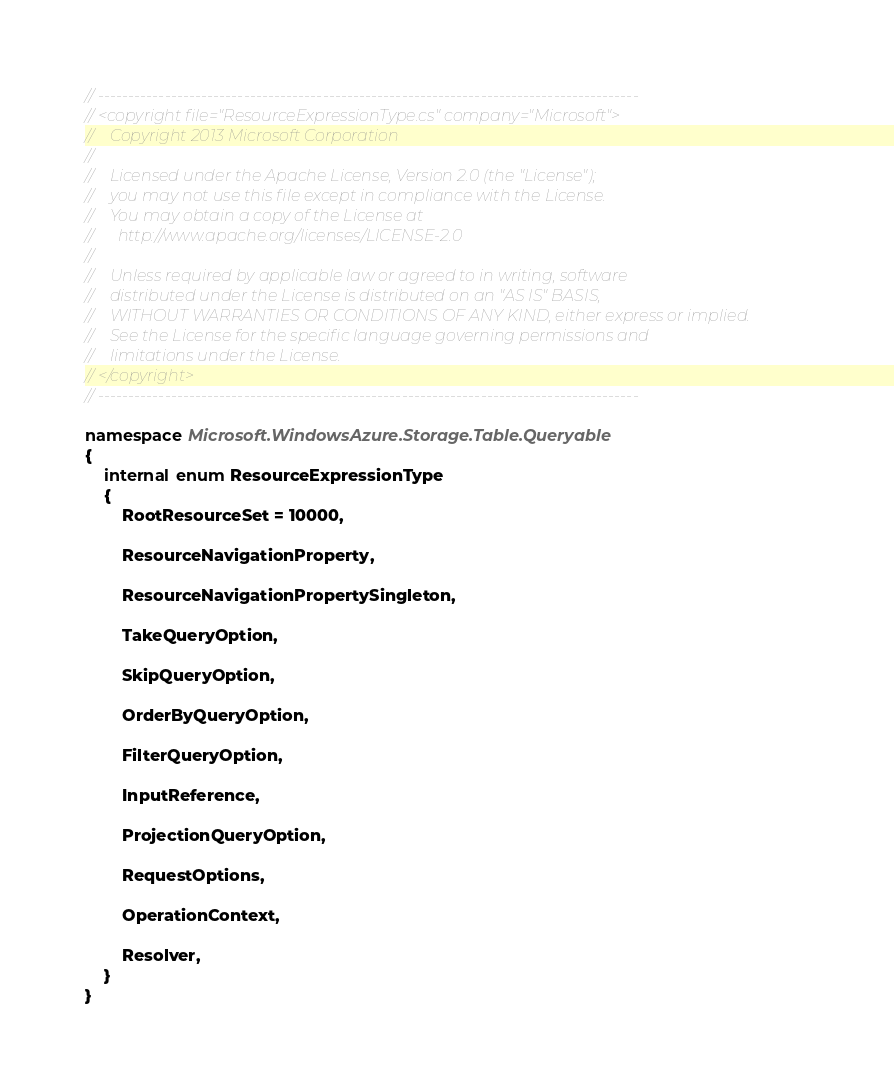Convert code to text. <code><loc_0><loc_0><loc_500><loc_500><_C#_>// -----------------------------------------------------------------------------------------
// <copyright file="ResourceExpressionType.cs" company="Microsoft">
//    Copyright 2013 Microsoft Corporation
// 
//    Licensed under the Apache License, Version 2.0 (the "License");
//    you may not use this file except in compliance with the License.
//    You may obtain a copy of the License at
//      http://www.apache.org/licenses/LICENSE-2.0
// 
//    Unless required by applicable law or agreed to in writing, software
//    distributed under the License is distributed on an "AS IS" BASIS,
//    WITHOUT WARRANTIES OR CONDITIONS OF ANY KIND, either express or implied.
//    See the License for the specific language governing permissions and
//    limitations under the License.
// </copyright>
// -----------------------------------------------------------------------------------------

namespace Microsoft.WindowsAzure.Storage.Table.Queryable
{
    internal enum ResourceExpressionType
    {
        RootResourceSet = 10000,

        ResourceNavigationProperty,

        ResourceNavigationPropertySingleton,

        TakeQueryOption,

        SkipQueryOption,

        OrderByQueryOption,

        FilterQueryOption,

        InputReference,

        ProjectionQueryOption,

        RequestOptions,

        OperationContext,

        Resolver,
    }
}
</code> 